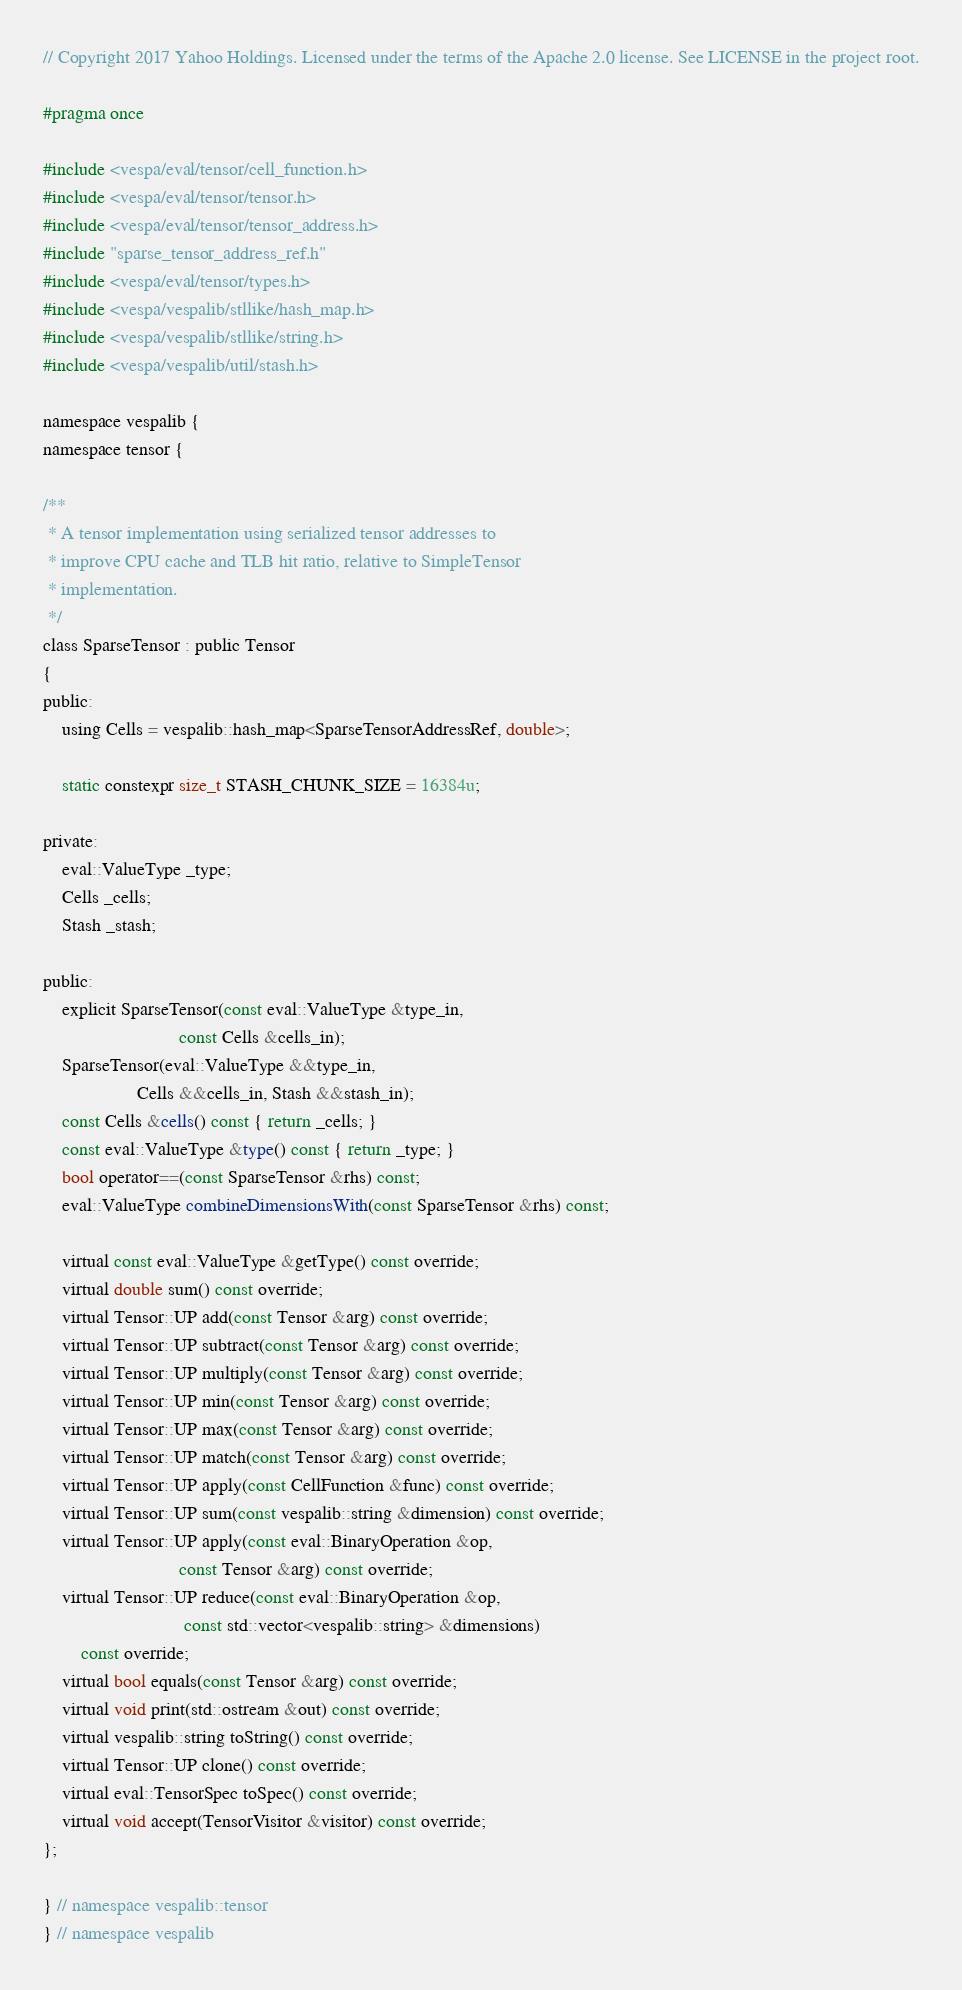Convert code to text. <code><loc_0><loc_0><loc_500><loc_500><_C_>// Copyright 2017 Yahoo Holdings. Licensed under the terms of the Apache 2.0 license. See LICENSE in the project root.

#pragma once

#include <vespa/eval/tensor/cell_function.h>
#include <vespa/eval/tensor/tensor.h>
#include <vespa/eval/tensor/tensor_address.h>
#include "sparse_tensor_address_ref.h"
#include <vespa/eval/tensor/types.h>
#include <vespa/vespalib/stllike/hash_map.h>
#include <vespa/vespalib/stllike/string.h>
#include <vespa/vespalib/util/stash.h>

namespace vespalib {
namespace tensor {

/**
 * A tensor implementation using serialized tensor addresses to
 * improve CPU cache and TLB hit ratio, relative to SimpleTensor
 * implementation.
 */
class SparseTensor : public Tensor
{
public:
    using Cells = vespalib::hash_map<SparseTensorAddressRef, double>;

    static constexpr size_t STASH_CHUNK_SIZE = 16384u;

private:
    eval::ValueType _type;
    Cells _cells;
    Stash _stash;

public:
    explicit SparseTensor(const eval::ValueType &type_in,
                             const Cells &cells_in);
    SparseTensor(eval::ValueType &&type_in,
                    Cells &&cells_in, Stash &&stash_in);
    const Cells &cells() const { return _cells; }
    const eval::ValueType &type() const { return _type; }
    bool operator==(const SparseTensor &rhs) const;
    eval::ValueType combineDimensionsWith(const SparseTensor &rhs) const;

    virtual const eval::ValueType &getType() const override;
    virtual double sum() const override;
    virtual Tensor::UP add(const Tensor &arg) const override;
    virtual Tensor::UP subtract(const Tensor &arg) const override;
    virtual Tensor::UP multiply(const Tensor &arg) const override;
    virtual Tensor::UP min(const Tensor &arg) const override;
    virtual Tensor::UP max(const Tensor &arg) const override;
    virtual Tensor::UP match(const Tensor &arg) const override;
    virtual Tensor::UP apply(const CellFunction &func) const override;
    virtual Tensor::UP sum(const vespalib::string &dimension) const override;
    virtual Tensor::UP apply(const eval::BinaryOperation &op,
                             const Tensor &arg) const override;
    virtual Tensor::UP reduce(const eval::BinaryOperation &op,
                              const std::vector<vespalib::string> &dimensions)
        const override;
    virtual bool equals(const Tensor &arg) const override;
    virtual void print(std::ostream &out) const override;
    virtual vespalib::string toString() const override;
    virtual Tensor::UP clone() const override;
    virtual eval::TensorSpec toSpec() const override;
    virtual void accept(TensorVisitor &visitor) const override;
};

} // namespace vespalib::tensor
} // namespace vespalib
</code> 